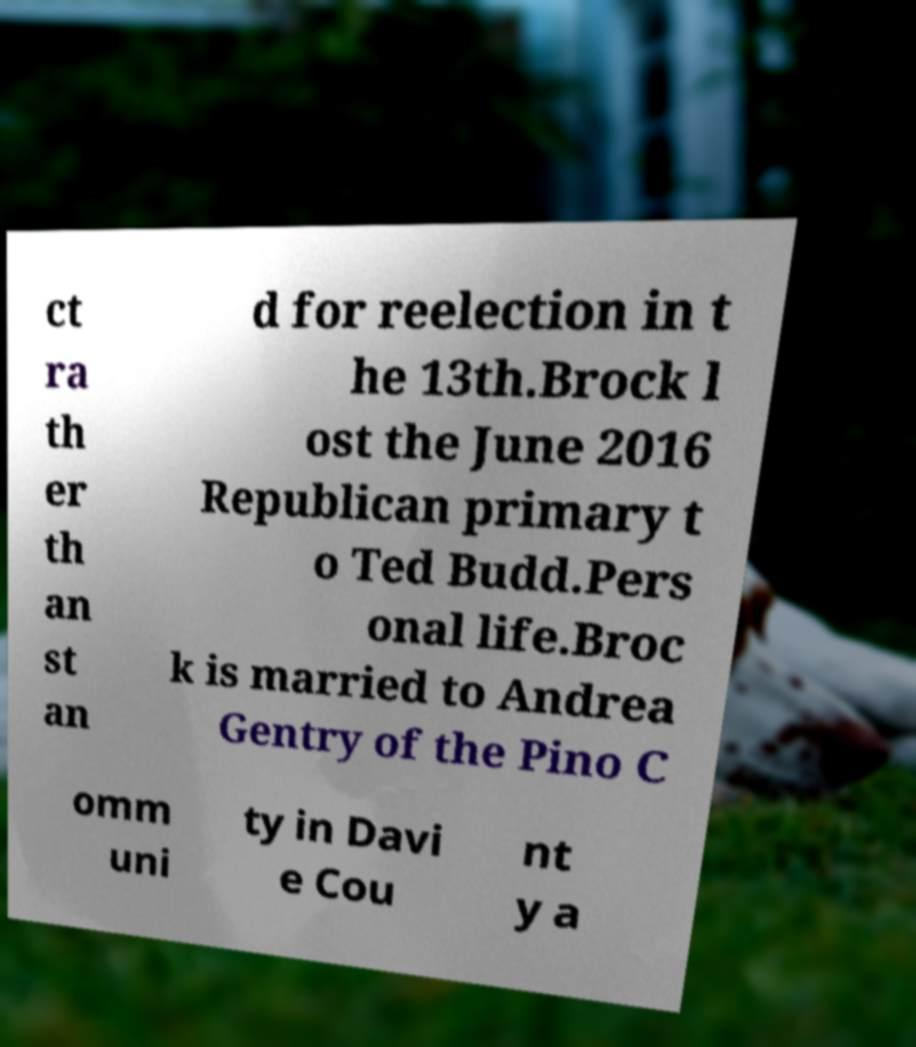Please identify and transcribe the text found in this image. ct ra th er th an st an d for reelection in t he 13th.Brock l ost the June 2016 Republican primary t o Ted Budd.Pers onal life.Broc k is married to Andrea Gentry of the Pino C omm uni ty in Davi e Cou nt y a 